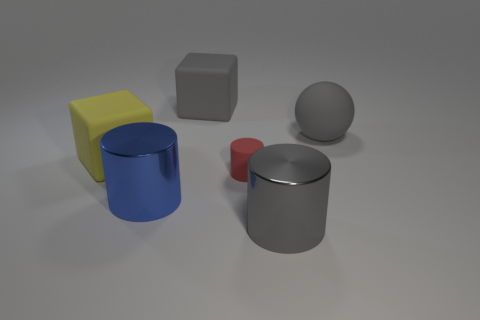Is the material of the large block that is behind the large ball the same as the gray cylinder?
Offer a terse response. No. There is another metal object that is the same shape as the large blue metal thing; what is its color?
Make the answer very short. Gray. What number of other things are the same color as the rubber sphere?
Provide a succinct answer. 2. There is a gray thing behind the matte ball; is its shape the same as the metallic thing that is on the left side of the gray shiny cylinder?
Keep it short and to the point. No. What number of cylinders are gray metallic objects or big gray matte objects?
Make the answer very short. 1. Are there fewer big gray shiny objects behind the big gray matte sphere than small red matte cylinders?
Your response must be concise. Yes. What number of other things are the same material as the gray ball?
Provide a succinct answer. 3. Is the size of the gray metal object the same as the yellow rubber block?
Provide a succinct answer. Yes. What number of objects are either large things that are behind the small red cylinder or gray shiny cylinders?
Offer a terse response. 4. What material is the large gray object to the left of the matte thing in front of the big yellow thing?
Give a very brief answer. Rubber. 